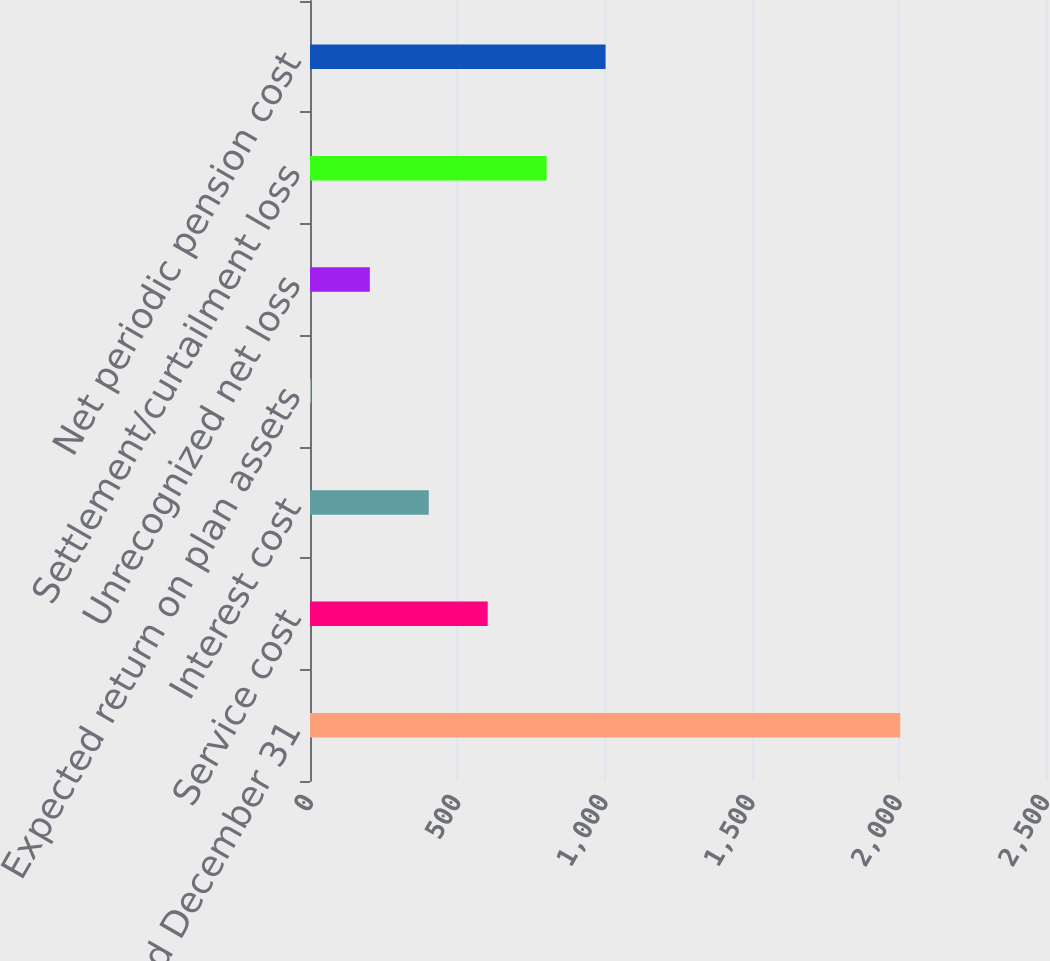Convert chart to OTSL. <chart><loc_0><loc_0><loc_500><loc_500><bar_chart><fcel>Years Ended December 31<fcel>Service cost<fcel>Interest cost<fcel>Expected return on plan assets<fcel>Unrecognized net loss<fcel>Settlement/curtailment loss<fcel>Net periodic pension cost<nl><fcel>2005<fcel>603.6<fcel>403.4<fcel>3<fcel>203.2<fcel>803.8<fcel>1004<nl></chart> 